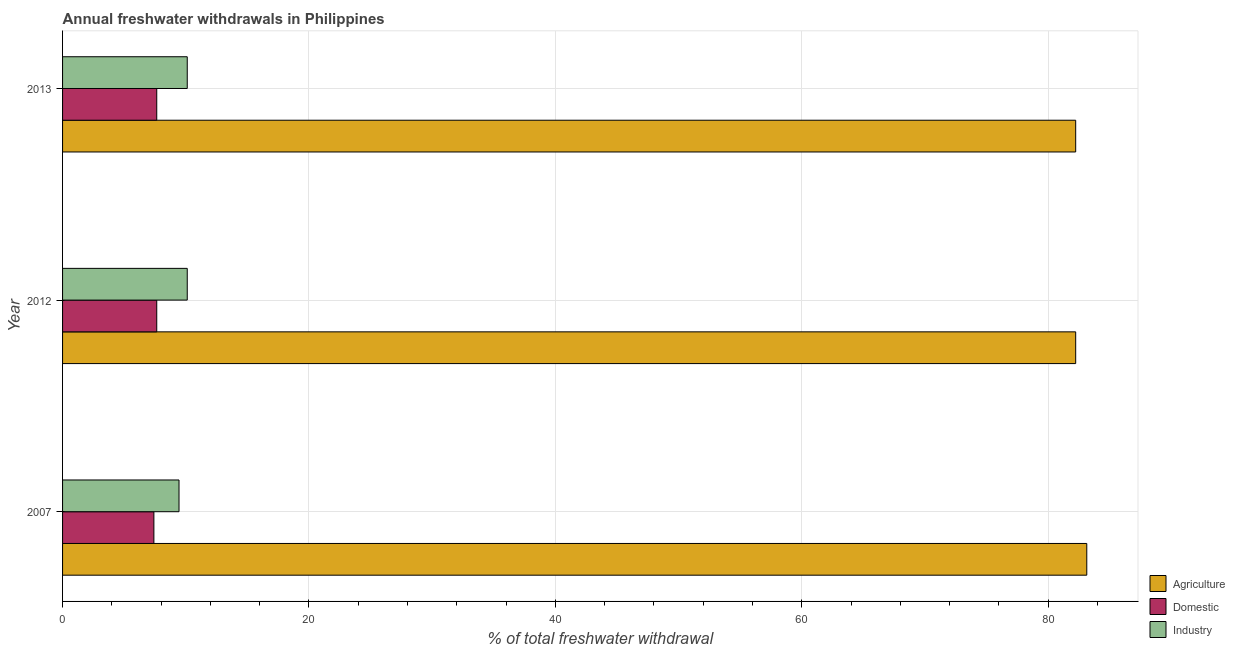How many different coloured bars are there?
Your answer should be compact. 3. How many groups of bars are there?
Keep it short and to the point. 3. Are the number of bars per tick equal to the number of legend labels?
Make the answer very short. Yes. Are the number of bars on each tick of the Y-axis equal?
Your answer should be compact. Yes. How many bars are there on the 3rd tick from the top?
Your response must be concise. 3. What is the label of the 3rd group of bars from the top?
Offer a very short reply. 2007. What is the percentage of freshwater withdrawal for industry in 2007?
Your answer should be compact. 9.45. Across all years, what is the maximum percentage of freshwater withdrawal for domestic purposes?
Make the answer very short. 7.64. Across all years, what is the minimum percentage of freshwater withdrawal for industry?
Offer a very short reply. 9.45. In which year was the percentage of freshwater withdrawal for agriculture maximum?
Keep it short and to the point. 2007. In which year was the percentage of freshwater withdrawal for industry minimum?
Offer a very short reply. 2007. What is the total percentage of freshwater withdrawal for agriculture in the graph?
Ensure brevity in your answer.  247.59. What is the difference between the percentage of freshwater withdrawal for industry in 2007 and the percentage of freshwater withdrawal for agriculture in 2013?
Give a very brief answer. -72.78. What is the average percentage of freshwater withdrawal for domestic purposes per year?
Your answer should be compact. 7.57. In the year 2012, what is the difference between the percentage of freshwater withdrawal for industry and percentage of freshwater withdrawal for domestic purposes?
Provide a succinct answer. 2.48. What is the ratio of the percentage of freshwater withdrawal for agriculture in 2012 to that in 2013?
Your answer should be very brief. 1. What is the difference between the highest and the second highest percentage of freshwater withdrawal for agriculture?
Your answer should be compact. 0.9. What does the 3rd bar from the top in 2013 represents?
Your answer should be very brief. Agriculture. What does the 2nd bar from the bottom in 2007 represents?
Your answer should be very brief. Domestic. Are all the bars in the graph horizontal?
Give a very brief answer. Yes. Does the graph contain any zero values?
Give a very brief answer. No. Does the graph contain grids?
Keep it short and to the point. Yes. Where does the legend appear in the graph?
Your answer should be very brief. Bottom right. How are the legend labels stacked?
Provide a short and direct response. Vertical. What is the title of the graph?
Offer a terse response. Annual freshwater withdrawals in Philippines. What is the label or title of the X-axis?
Make the answer very short. % of total freshwater withdrawal. What is the % of total freshwater withdrawal in Agriculture in 2007?
Your answer should be very brief. 83.13. What is the % of total freshwater withdrawal in Domestic in 2007?
Your answer should be compact. 7.41. What is the % of total freshwater withdrawal of Industry in 2007?
Your response must be concise. 9.45. What is the % of total freshwater withdrawal in Agriculture in 2012?
Your answer should be very brief. 82.23. What is the % of total freshwater withdrawal of Domestic in 2012?
Make the answer very short. 7.64. What is the % of total freshwater withdrawal in Industry in 2012?
Your answer should be compact. 10.12. What is the % of total freshwater withdrawal in Agriculture in 2013?
Your answer should be compact. 82.23. What is the % of total freshwater withdrawal in Domestic in 2013?
Your answer should be compact. 7.64. What is the % of total freshwater withdrawal in Industry in 2013?
Offer a terse response. 10.12. Across all years, what is the maximum % of total freshwater withdrawal of Agriculture?
Offer a very short reply. 83.13. Across all years, what is the maximum % of total freshwater withdrawal of Domestic?
Keep it short and to the point. 7.64. Across all years, what is the maximum % of total freshwater withdrawal of Industry?
Make the answer very short. 10.12. Across all years, what is the minimum % of total freshwater withdrawal of Agriculture?
Offer a terse response. 82.23. Across all years, what is the minimum % of total freshwater withdrawal in Domestic?
Ensure brevity in your answer.  7.41. Across all years, what is the minimum % of total freshwater withdrawal of Industry?
Provide a short and direct response. 9.45. What is the total % of total freshwater withdrawal of Agriculture in the graph?
Ensure brevity in your answer.  247.59. What is the total % of total freshwater withdrawal in Domestic in the graph?
Your answer should be very brief. 22.7. What is the total % of total freshwater withdrawal in Industry in the graph?
Your response must be concise. 29.69. What is the difference between the % of total freshwater withdrawal in Domestic in 2007 and that in 2012?
Your response must be concise. -0.23. What is the difference between the % of total freshwater withdrawal of Industry in 2007 and that in 2012?
Keep it short and to the point. -0.67. What is the difference between the % of total freshwater withdrawal in Domestic in 2007 and that in 2013?
Offer a very short reply. -0.23. What is the difference between the % of total freshwater withdrawal in Industry in 2007 and that in 2013?
Give a very brief answer. -0.67. What is the difference between the % of total freshwater withdrawal in Domestic in 2012 and that in 2013?
Your answer should be very brief. 0. What is the difference between the % of total freshwater withdrawal in Industry in 2012 and that in 2013?
Keep it short and to the point. 0. What is the difference between the % of total freshwater withdrawal of Agriculture in 2007 and the % of total freshwater withdrawal of Domestic in 2012?
Your answer should be compact. 75.48. What is the difference between the % of total freshwater withdrawal of Agriculture in 2007 and the % of total freshwater withdrawal of Industry in 2012?
Keep it short and to the point. 73.01. What is the difference between the % of total freshwater withdrawal in Domestic in 2007 and the % of total freshwater withdrawal in Industry in 2012?
Offer a terse response. -2.71. What is the difference between the % of total freshwater withdrawal of Agriculture in 2007 and the % of total freshwater withdrawal of Domestic in 2013?
Provide a short and direct response. 75.48. What is the difference between the % of total freshwater withdrawal in Agriculture in 2007 and the % of total freshwater withdrawal in Industry in 2013?
Your answer should be very brief. 73.01. What is the difference between the % of total freshwater withdrawal in Domestic in 2007 and the % of total freshwater withdrawal in Industry in 2013?
Offer a very short reply. -2.71. What is the difference between the % of total freshwater withdrawal of Agriculture in 2012 and the % of total freshwater withdrawal of Domestic in 2013?
Provide a succinct answer. 74.58. What is the difference between the % of total freshwater withdrawal of Agriculture in 2012 and the % of total freshwater withdrawal of Industry in 2013?
Offer a terse response. 72.11. What is the difference between the % of total freshwater withdrawal in Domestic in 2012 and the % of total freshwater withdrawal in Industry in 2013?
Offer a very short reply. -2.48. What is the average % of total freshwater withdrawal in Agriculture per year?
Keep it short and to the point. 82.53. What is the average % of total freshwater withdrawal in Domestic per year?
Make the answer very short. 7.57. What is the average % of total freshwater withdrawal in Industry per year?
Provide a succinct answer. 9.9. In the year 2007, what is the difference between the % of total freshwater withdrawal of Agriculture and % of total freshwater withdrawal of Domestic?
Offer a very short reply. 75.72. In the year 2007, what is the difference between the % of total freshwater withdrawal of Agriculture and % of total freshwater withdrawal of Industry?
Offer a terse response. 73.68. In the year 2007, what is the difference between the % of total freshwater withdrawal of Domestic and % of total freshwater withdrawal of Industry?
Your answer should be very brief. -2.04. In the year 2012, what is the difference between the % of total freshwater withdrawal of Agriculture and % of total freshwater withdrawal of Domestic?
Make the answer very short. 74.58. In the year 2012, what is the difference between the % of total freshwater withdrawal of Agriculture and % of total freshwater withdrawal of Industry?
Offer a terse response. 72.11. In the year 2012, what is the difference between the % of total freshwater withdrawal in Domestic and % of total freshwater withdrawal in Industry?
Your answer should be compact. -2.48. In the year 2013, what is the difference between the % of total freshwater withdrawal in Agriculture and % of total freshwater withdrawal in Domestic?
Your answer should be very brief. 74.58. In the year 2013, what is the difference between the % of total freshwater withdrawal in Agriculture and % of total freshwater withdrawal in Industry?
Make the answer very short. 72.11. In the year 2013, what is the difference between the % of total freshwater withdrawal of Domestic and % of total freshwater withdrawal of Industry?
Provide a succinct answer. -2.48. What is the ratio of the % of total freshwater withdrawal in Agriculture in 2007 to that in 2012?
Offer a terse response. 1.01. What is the ratio of the % of total freshwater withdrawal in Domestic in 2007 to that in 2012?
Your answer should be compact. 0.97. What is the ratio of the % of total freshwater withdrawal of Industry in 2007 to that in 2012?
Ensure brevity in your answer.  0.93. What is the ratio of the % of total freshwater withdrawal in Agriculture in 2007 to that in 2013?
Offer a very short reply. 1.01. What is the ratio of the % of total freshwater withdrawal of Domestic in 2007 to that in 2013?
Your answer should be compact. 0.97. What is the ratio of the % of total freshwater withdrawal of Industry in 2007 to that in 2013?
Provide a succinct answer. 0.93. What is the ratio of the % of total freshwater withdrawal of Domestic in 2012 to that in 2013?
Provide a succinct answer. 1. What is the difference between the highest and the second highest % of total freshwater withdrawal of Agriculture?
Give a very brief answer. 0.9. What is the difference between the highest and the second highest % of total freshwater withdrawal in Domestic?
Provide a short and direct response. 0. What is the difference between the highest and the second highest % of total freshwater withdrawal of Industry?
Make the answer very short. 0. What is the difference between the highest and the lowest % of total freshwater withdrawal in Domestic?
Ensure brevity in your answer.  0.23. What is the difference between the highest and the lowest % of total freshwater withdrawal in Industry?
Ensure brevity in your answer.  0.67. 